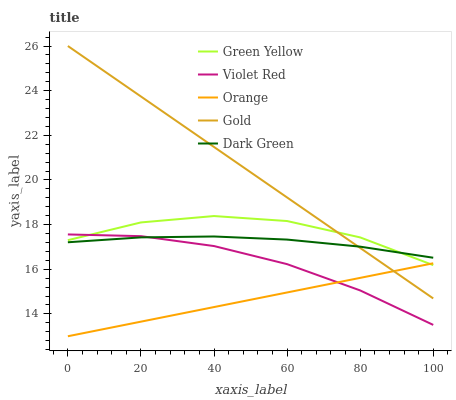Does Violet Red have the minimum area under the curve?
Answer yes or no. No. Does Violet Red have the maximum area under the curve?
Answer yes or no. No. Is Violet Red the smoothest?
Answer yes or no. No. Is Violet Red the roughest?
Answer yes or no. No. Does Violet Red have the lowest value?
Answer yes or no. No. Does Violet Red have the highest value?
Answer yes or no. No. Is Orange less than Dark Green?
Answer yes or no. Yes. Is Gold greater than Violet Red?
Answer yes or no. Yes. Does Orange intersect Dark Green?
Answer yes or no. No. 